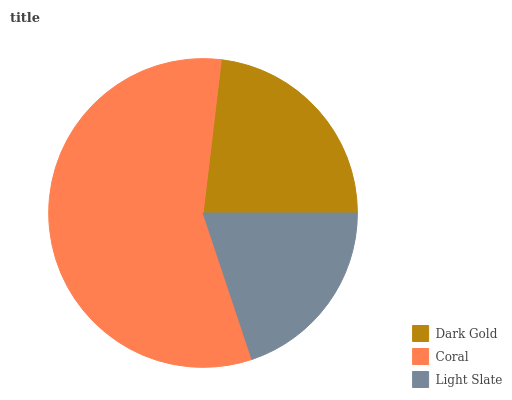Is Light Slate the minimum?
Answer yes or no. Yes. Is Coral the maximum?
Answer yes or no. Yes. Is Coral the minimum?
Answer yes or no. No. Is Light Slate the maximum?
Answer yes or no. No. Is Coral greater than Light Slate?
Answer yes or no. Yes. Is Light Slate less than Coral?
Answer yes or no. Yes. Is Light Slate greater than Coral?
Answer yes or no. No. Is Coral less than Light Slate?
Answer yes or no. No. Is Dark Gold the high median?
Answer yes or no. Yes. Is Dark Gold the low median?
Answer yes or no. Yes. Is Coral the high median?
Answer yes or no. No. Is Light Slate the low median?
Answer yes or no. No. 